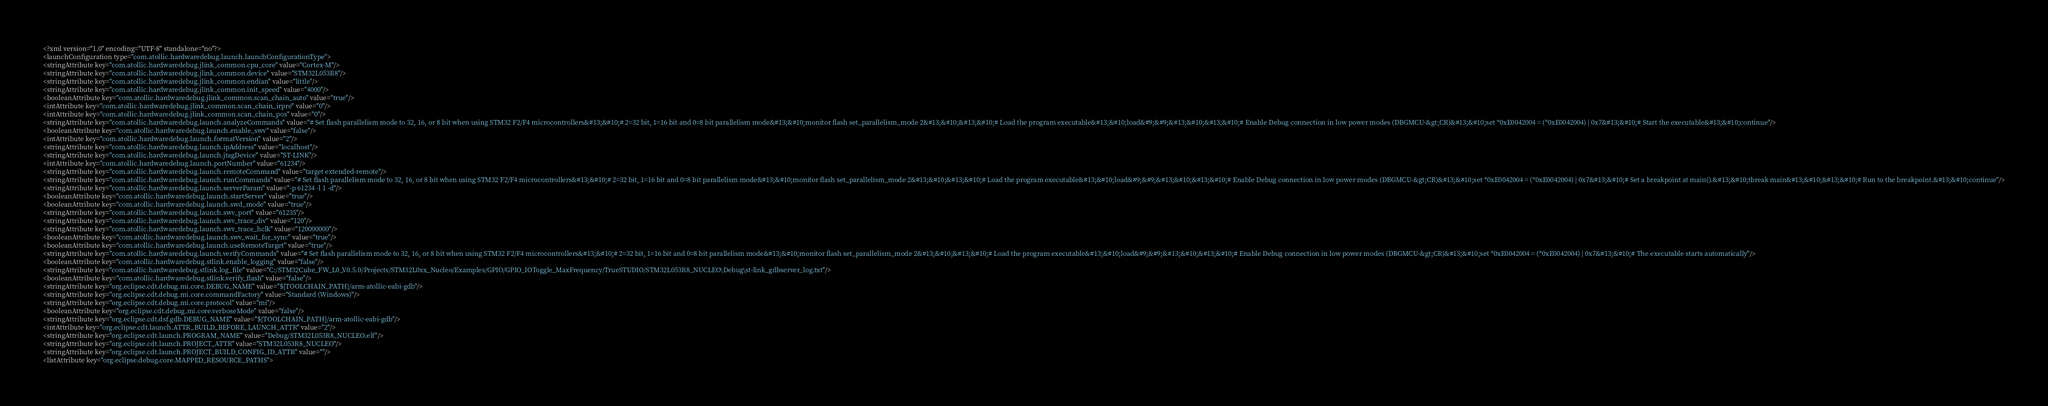<code> <loc_0><loc_0><loc_500><loc_500><_XML_><?xml version="1.0" encoding="UTF-8" standalone="no"?>
<launchConfiguration type="com.atollic.hardwaredebug.launch.launchConfigurationType">
<stringAttribute key="com.atollic.hardwaredebug.jlink_common.cpu_core" value="Cortex-M"/>
<stringAttribute key="com.atollic.hardwaredebug.jlink_common.device" value="STM32L053R8"/>
<stringAttribute key="com.atollic.hardwaredebug.jlink_common.endian" value="little"/>
<stringAttribute key="com.atollic.hardwaredebug.jlink_common.init_speed" value="4000"/>
<booleanAttribute key="com.atollic.hardwaredebug.jlink_common.scan_chain_auto" value="true"/>
<intAttribute key="com.atollic.hardwaredebug.jlink_common.scan_chain_irpre" value="0"/>
<intAttribute key="com.atollic.hardwaredebug.jlink_common.scan_chain_pos" value="0"/>
<stringAttribute key="com.atollic.hardwaredebug.launch.analyzeCommands" value="# Set flash parallelism mode to 32, 16, or 8 bit when using STM32 F2/F4 microcontrollers&#13;&#10;# 2=32 bit, 1=16 bit and 0=8 bit parallelism mode&#13;&#10;monitor flash set_parallelism_mode 2&#13;&#10;&#13;&#10;# Load the program executable&#13;&#10;load&#9;&#9;&#13;&#10;&#13;&#10;# Enable Debug connection in low power modes (DBGMCU-&gt;CR)&#13;&#10;set *0xE0042004 = (*0xE0042004) | 0x7&#13;&#10;# Start the executable&#13;&#10;continue"/>
<booleanAttribute key="com.atollic.hardwaredebug.launch.enable_swv" value="false"/>
<intAttribute key="com.atollic.hardwaredebug.launch.formatVersion" value="2"/>
<stringAttribute key="com.atollic.hardwaredebug.launch.ipAddress" value="localhost"/>
<stringAttribute key="com.atollic.hardwaredebug.launch.jtagDevice" value="ST-LINK"/>
<intAttribute key="com.atollic.hardwaredebug.launch.portNumber" value="61234"/>
<stringAttribute key="com.atollic.hardwaredebug.launch.remoteCommand" value="target extended-remote"/>
<stringAttribute key="com.atollic.hardwaredebug.launch.runCommands" value="# Set flash parallelism mode to 32, 16, or 8 bit when using STM32 F2/F4 microcontrollers&#13;&#10;# 2=32 bit, 1=16 bit and 0=8 bit parallelism mode&#13;&#10;monitor flash set_parallelism_mode 2&#13;&#10;&#13;&#10;# Load the program executable&#13;&#10;load&#9;&#9;&#13;&#10;&#13;&#10;# Enable Debug connection in low power modes (DBGMCU-&gt;CR)&#13;&#10;set *0xE0042004 = (*0xE0042004) | 0x7&#13;&#10;# Set a breakpoint at main().&#13;&#10;tbreak main&#13;&#10;&#13;&#10;# Run to the breakpoint.&#13;&#10;continue"/>
<stringAttribute key="com.atollic.hardwaredebug.launch.serverParam" value="-p 61234 -l 1 -d"/>
<booleanAttribute key="com.atollic.hardwaredebug.launch.startServer" value="true"/>
<booleanAttribute key="com.atollic.hardwaredebug.launch.swd_mode" value="true"/>
<stringAttribute key="com.atollic.hardwaredebug.launch.swv_port" value="61235"/>
<stringAttribute key="com.atollic.hardwaredebug.launch.swv_trace_div" value="120"/>
<stringAttribute key="com.atollic.hardwaredebug.launch.swv_trace_hclk" value="120000000"/>
<booleanAttribute key="com.atollic.hardwaredebug.launch.swv_wait_for_sync" value="true"/>
<booleanAttribute key="com.atollic.hardwaredebug.launch.useRemoteTarget" value="true"/>
<stringAttribute key="com.atollic.hardwaredebug.launch.verifyCommands" value="# Set flash parallelism mode to 32, 16, or 8 bit when using STM32 F2/F4 microcontrollers&#13;&#10;# 2=32 bit, 1=16 bit and 0=8 bit parallelism mode&#13;&#10;monitor flash set_parallelism_mode 2&#13;&#10;&#13;&#10;# Load the program executable&#13;&#10;load&#9;&#9;&#13;&#10;&#13;&#10;# Enable Debug connection in low power modes (DBGMCU-&gt;CR)&#13;&#10;set *0xE0042004 = (*0xE0042004) | 0x7&#13;&#10;# The executable starts automatically"/>
<booleanAttribute key="com.atollic.hardwaredebug.stlink.enable_logging" value="false"/>
<stringAttribute key="com.atollic.hardwaredebug.stlink.log_file" value="C:/STM32Cube_FW_L0_V0.5.0/Projects/STM32L0xx_Nucleo/Examples/GPIO/GPIO_IOToggle_MaxFrequency/TrueSTUDIO/STM32L053R8_NUCLEO\Debug\st-link_gdbserver_log.txt"/>
<booleanAttribute key="com.atollic.hardwaredebug.stlink.verify_flash" value="false"/>
<stringAttribute key="org.eclipse.cdt.debug.mi.core.DEBUG_NAME" value="${TOOLCHAIN_PATH}/arm-atollic-eabi-gdb"/>
<stringAttribute key="org.eclipse.cdt.debug.mi.core.commandFactory" value="Standard (Windows)"/>
<stringAttribute key="org.eclipse.cdt.debug.mi.core.protocol" value="mi"/>
<booleanAttribute key="org.eclipse.cdt.debug.mi.core.verboseMode" value="false"/>
<stringAttribute key="org.eclipse.cdt.dsf.gdb.DEBUG_NAME" value="${TOOLCHAIN_PATH}/arm-atollic-eabi-gdb"/>
<intAttribute key="org.eclipse.cdt.launch.ATTR_BUILD_BEFORE_LAUNCH_ATTR" value="2"/>
<stringAttribute key="org.eclipse.cdt.launch.PROGRAM_NAME" value="Debug/STM32L053R8_NUCLEO.elf"/>
<stringAttribute key="org.eclipse.cdt.launch.PROJECT_ATTR" value="STM32L053R8_NUCLEO"/>
<stringAttribute key="org.eclipse.cdt.launch.PROJECT_BUILD_CONFIG_ID_ATTR" value=""/>
<listAttribute key="org.eclipse.debug.core.MAPPED_RESOURCE_PATHS"></code> 